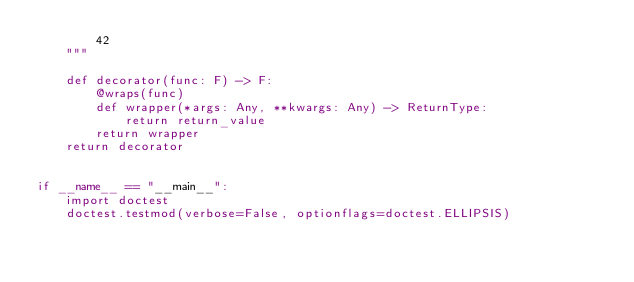<code> <loc_0><loc_0><loc_500><loc_500><_Python_>        42
    """

    def decorator(func: F) -> F:
        @wraps(func)
        def wrapper(*args: Any, **kwargs: Any) -> ReturnType:
            return return_value
        return wrapper
    return decorator


if __name__ == "__main__":
    import doctest
    doctest.testmod(verbose=False, optionflags=doctest.ELLIPSIS)
</code> 